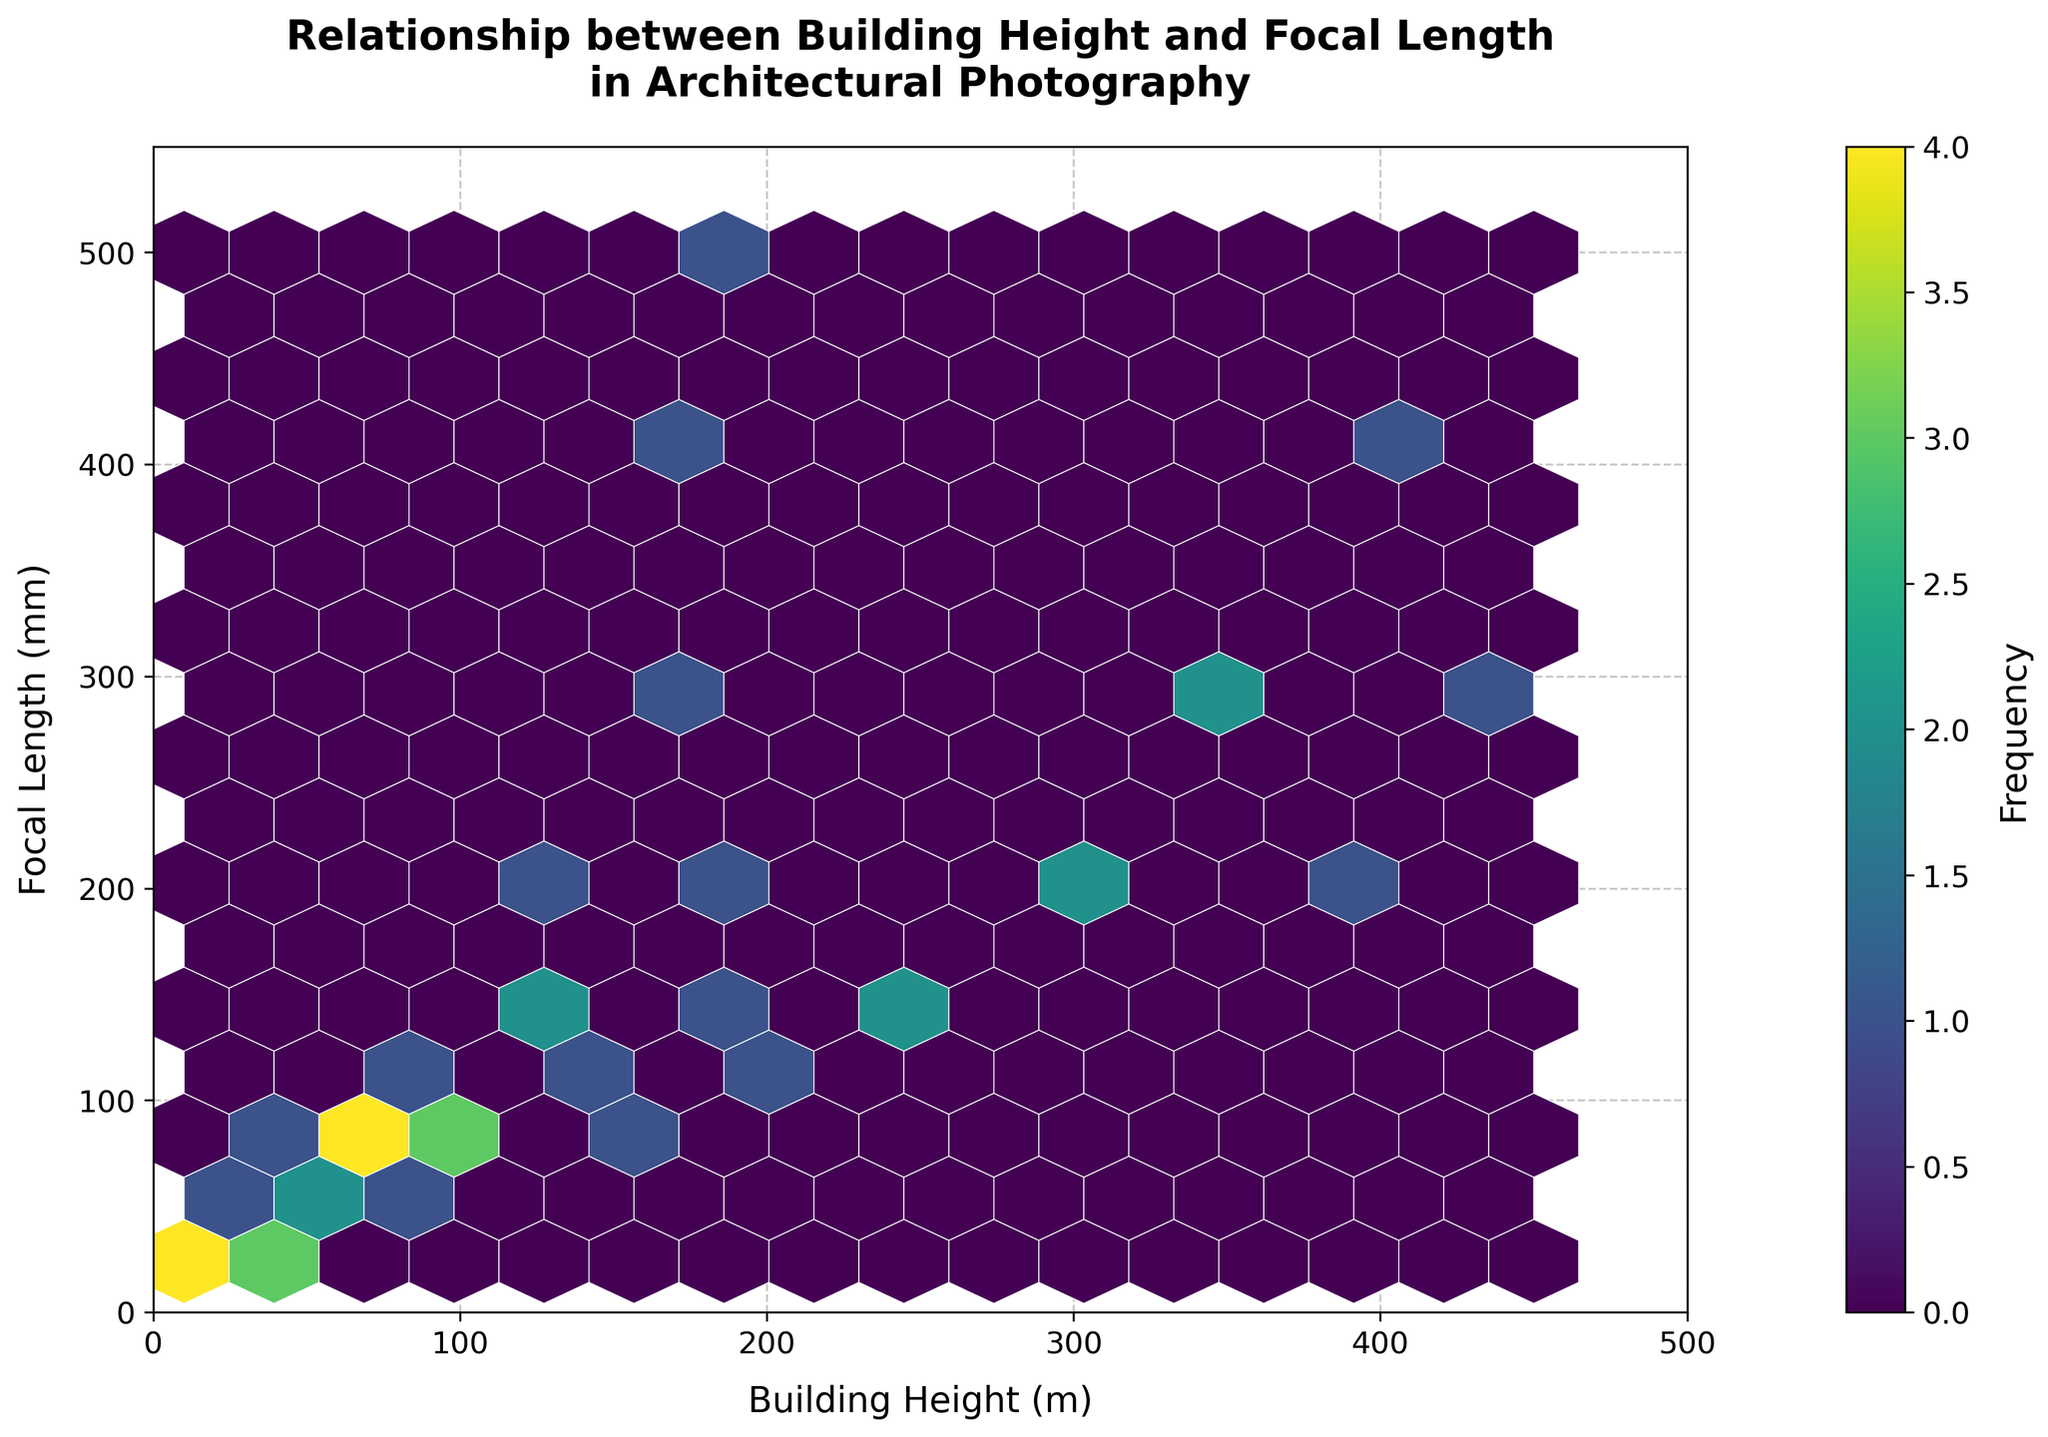What's the title of the Hexbin Plot? The title is displayed prominently at the top of the plot, usually in bold and larger font size, making it easily identifiable.
Answer: Relationship between Building Height and Focal Length in Architectural Photography What does the color intensity represent in this hexbin plot? The color intensity in a hexbin plot typically represents the frequency or density of data points within each hexagonal bin, which is indicated by the color bar on the right side of the plot.
Answer: Frequency What is the range of the x-axis representing Building Heights? The x-axis represents Building Heights, and its range can be observed from the minimum to maximum values labeled on the axis.
Answer: 0 to 500 meters What is the range of the y-axis representing Focal Lengths? The y-axis represents Focal Lengths, and its range can be determined from the minimum to maximum values labeled on the axis.
Answer: 0 to 550 millimeters How does the focal length trend as the building height increases? By examining the hexbin plot, we can observe that the focal lengths generally increase as the building height increases, evidenced by the clustering of data points towards higher values on both axes.
Answer: Increases Which combination of building heights and focal lengths seems most frequent? The densest hexagon, indicated by the darkest color, shows the most frequent combination of building heights and focal lengths. This typically involves inspecting the color bar and related plot areas.
Answer: Around 50 meters in Building Height and 50 millimeters in Focal Length Is there any building height with a focal length of 400mm? We need to check if any hexbin touches or overlaps with the y-axis value of 400mm, inspecting the corresponding x-axis values.
Answer: Yes, building heights around 350 meters and 400 meters At what building height do we first see a focal length of 500mm? By looking at the y-axis value of 500mm and tracing it horizontally to where it intersects a hexbin, we can find the smallest x-axis value (building height) at this intersection.
Answer: 200 meters How many distinct focal length ranges are visibly used for buildings taller than 300 meters? Determine the focal length ranges for building heights greater than 300 meters by examining the hexagonal bins within that specific x-axis range and noting the distinct y-axis ranges they span.
Answer: Three distinct ranges (200mm, 300mm, and 400-500mm) What's the average building height for the most frequent focal length observed? Identify the focal length with the highest frequency (darkest hexbin) and then average the building heights associated with that focal length by investigating the surrounding hexbin values.
Answer: Approx. 50 meters 